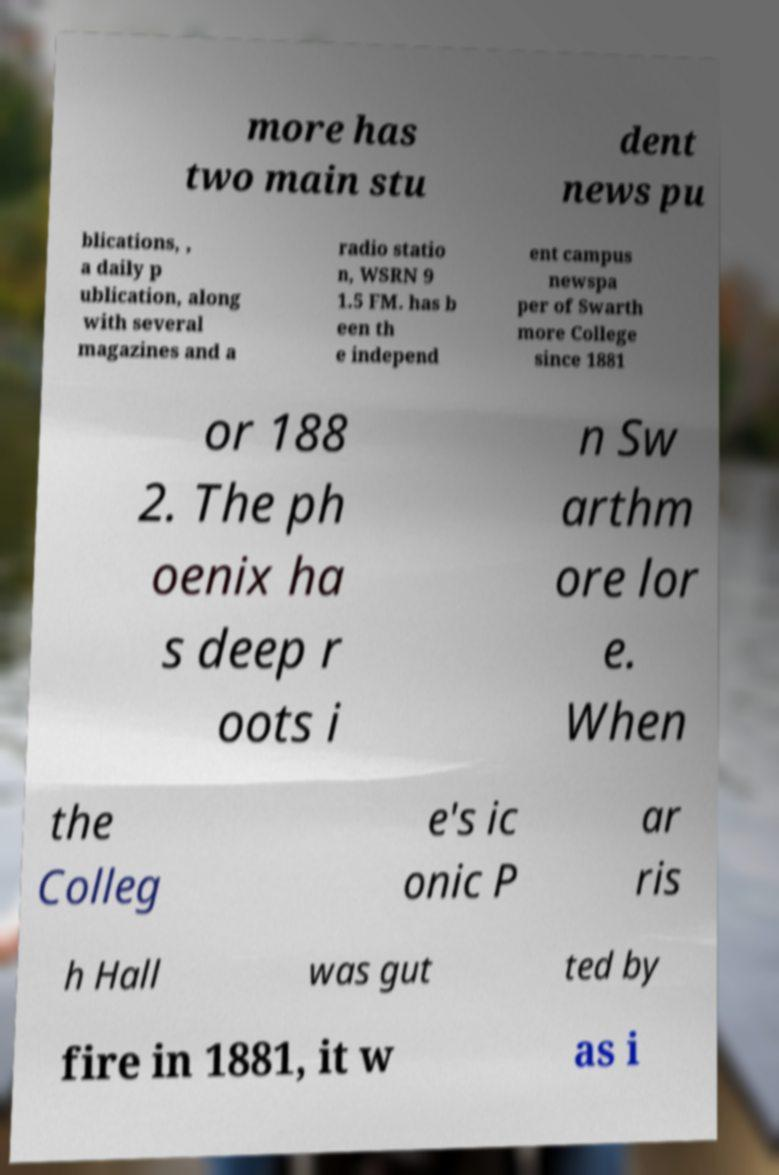Could you assist in decoding the text presented in this image and type it out clearly? more has two main stu dent news pu blications, , a daily p ublication, along with several magazines and a radio statio n, WSRN 9 1.5 FM. has b een th e independ ent campus newspa per of Swarth more College since 1881 or 188 2. The ph oenix ha s deep r oots i n Sw arthm ore lor e. When the Colleg e's ic onic P ar ris h Hall was gut ted by fire in 1881, it w as i 